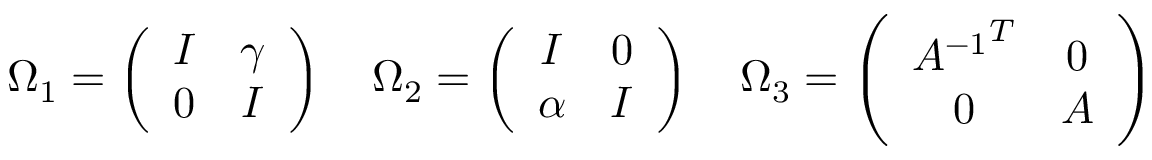Convert formula to latex. <formula><loc_0><loc_0><loc_500><loc_500>\Omega _ { 1 } = \left ( \begin{array} { c c } { I } & { \gamma } \\ { 0 } & { I } \end{array} \right ) \quad \Omega _ { 2 } = \left ( \begin{array} { c c } { I } & { 0 } \\ { \alpha } & { I } \end{array} \right ) \quad \Omega _ { 3 } = \left ( \begin{array} { c c } { { { A ^ { - 1 } } ^ { T } } } & { 0 } \\ { 0 } & { A } \end{array} \right )</formula> 